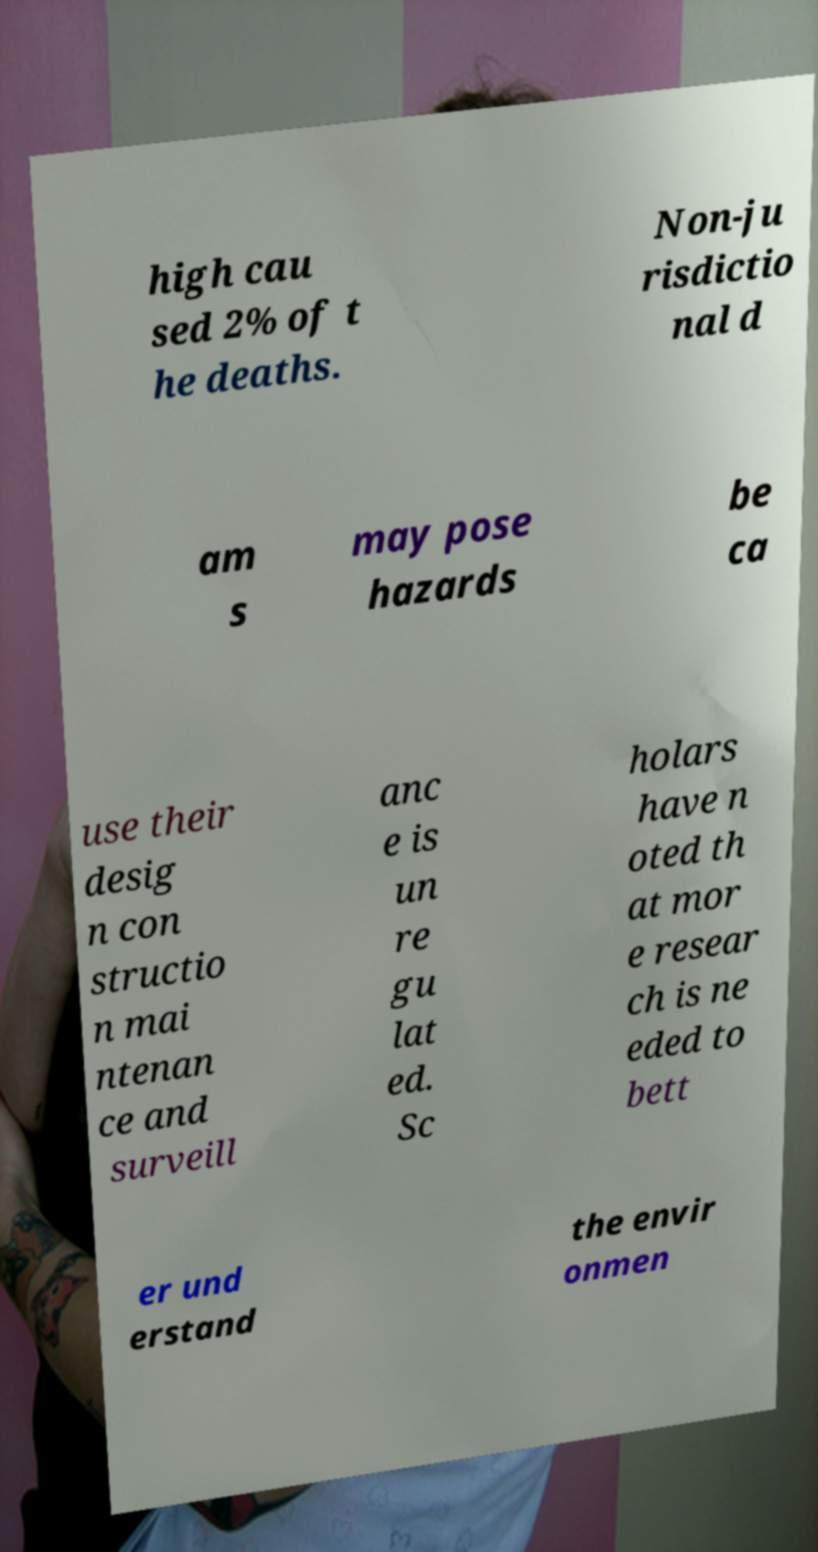Please identify and transcribe the text found in this image. high cau sed 2% of t he deaths. Non-ju risdictio nal d am s may pose hazards be ca use their desig n con structio n mai ntenan ce and surveill anc e is un re gu lat ed. Sc holars have n oted th at mor e resear ch is ne eded to bett er und erstand the envir onmen 